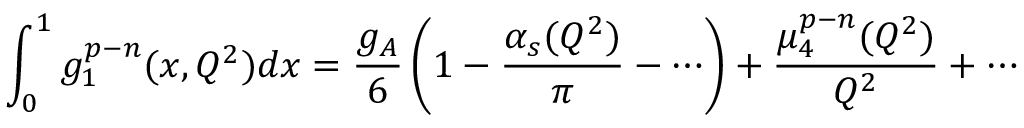Convert formula to latex. <formula><loc_0><loc_0><loc_500><loc_500>\int _ { 0 } ^ { 1 } g _ { 1 } ^ { p - n } ( x , Q ^ { 2 } ) d x = { \frac { g _ { A } } { 6 } } \left ( 1 - { \frac { \alpha _ { s } ( Q ^ { 2 } ) } { \pi } } - \cdots \right ) + { \frac { \mu _ { 4 } ^ { p - n } ( Q ^ { 2 } ) } { Q ^ { 2 } } } + \cdots</formula> 